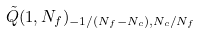<formula> <loc_0><loc_0><loc_500><loc_500>\tilde { Q } ( 1 , N _ { f } ) _ { - 1 / ( N _ { f } - N _ { c } ) , N _ { c } / N _ { f } }</formula> 